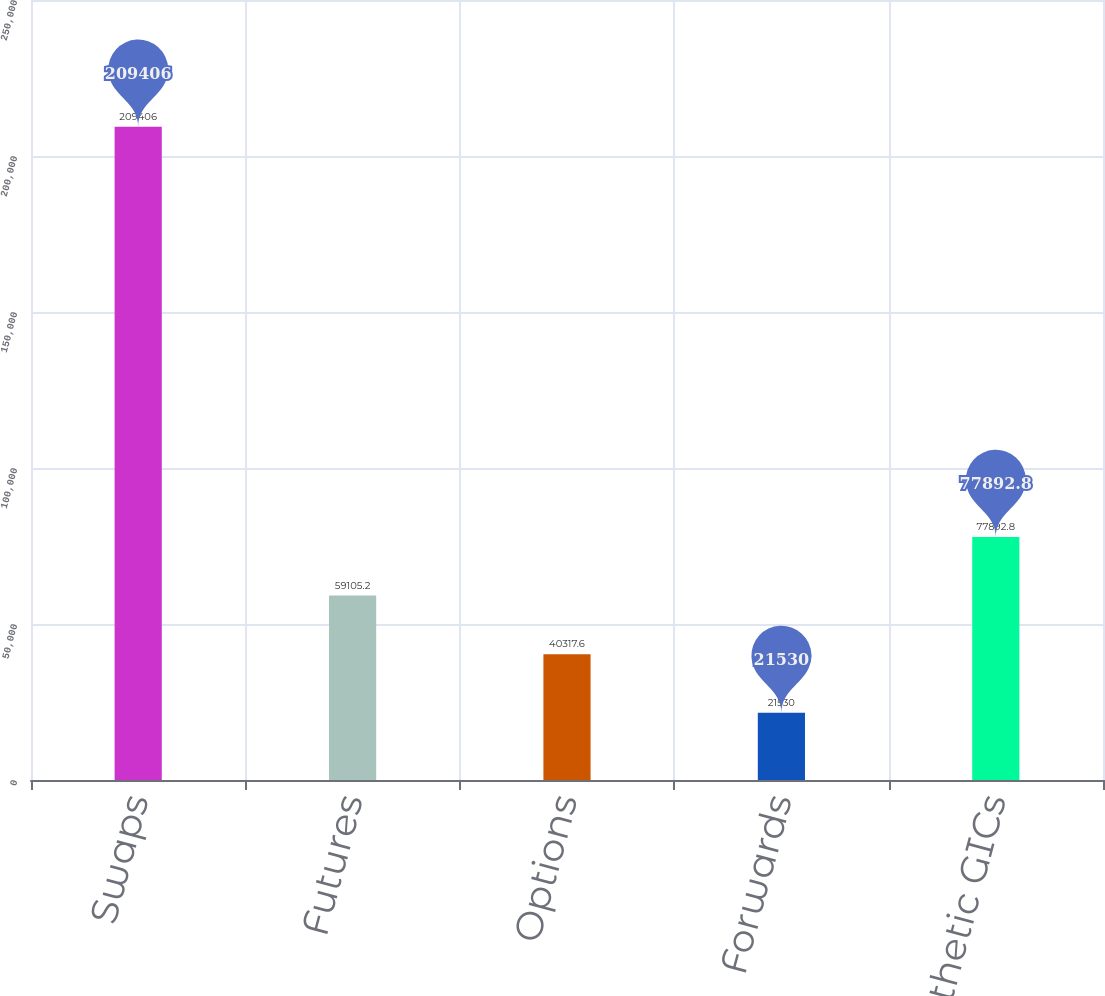Convert chart to OTSL. <chart><loc_0><loc_0><loc_500><loc_500><bar_chart><fcel>Swaps<fcel>Futures<fcel>Options<fcel>Forwards<fcel>Synthetic GICs<nl><fcel>209406<fcel>59105.2<fcel>40317.6<fcel>21530<fcel>77892.8<nl></chart> 